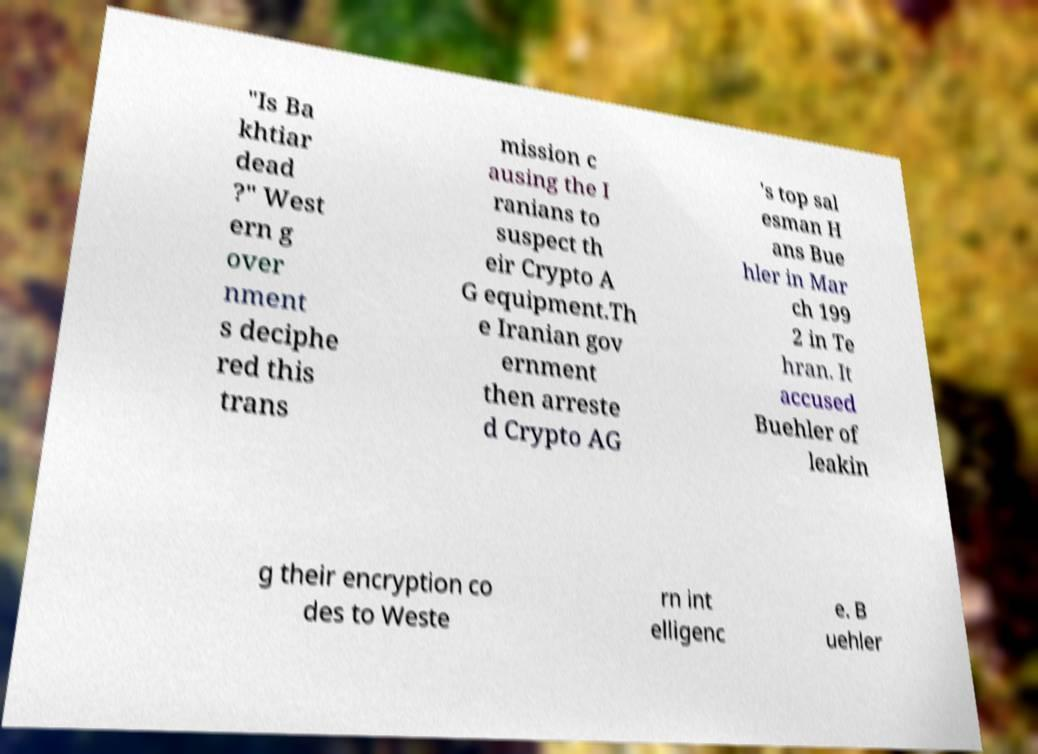For documentation purposes, I need the text within this image transcribed. Could you provide that? "Is Ba khtiar dead ?" West ern g over nment s deciphe red this trans mission c ausing the I ranians to suspect th eir Crypto A G equipment.Th e Iranian gov ernment then arreste d Crypto AG 's top sal esman H ans Bue hler in Mar ch 199 2 in Te hran. It accused Buehler of leakin g their encryption co des to Weste rn int elligenc e. B uehler 